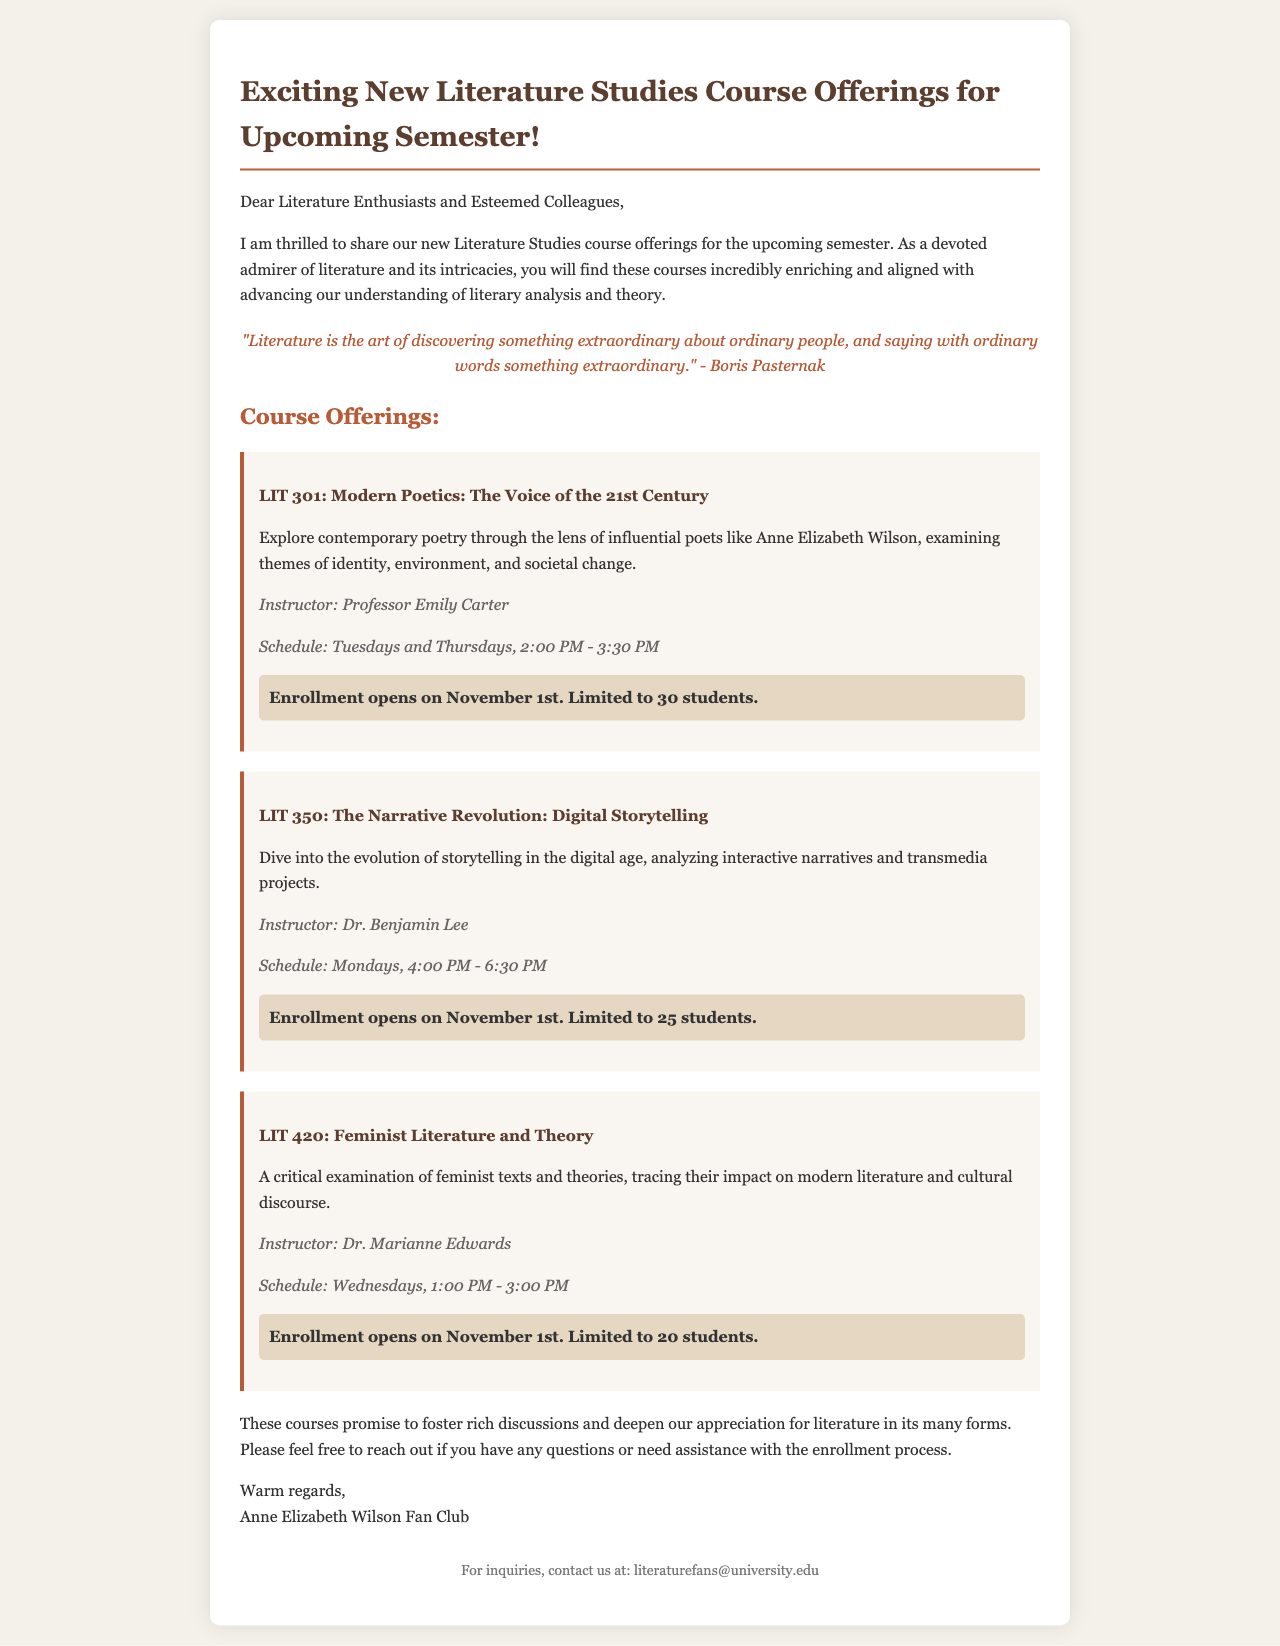What is the title of the program? The title of the program is located at the top of the document, presenting the subject of the courses offered.
Answer: Exciting New Literature Studies Course Offerings for Upcoming Semester Who is the instructor for LIT 301? The instructor’s name for LIT 301 is presented within the course description section.
Answer: Professor Emily Carter How many students are limited for enrollment in LIT 350? The document specifies limitations for enrollment within the respective course details.
Answer: 25 students What day and time does LIT 420 take place? The schedule information for LIT 420 is detailed in the course description.
Answer: Wednesdays, 1:00 PM - 3:00 PM When does enrollment open for all courses? The enrollment opening date for each course is mentioned in the enrollment information sections.
Answer: November 1st What type of course is LIT 350? The type of course refers to its thematic focus as described in the course listing.
Answer: Digital Storytelling Who can be contacted for inquiries? The contact for inquiries is given in the footer of the document.
Answer: literaturefans@university.edu What is the focus of LIT 420? The focus of LIT 420 can be summarized based on the topic given in its description.
Answer: Feminist Literature and Theory 